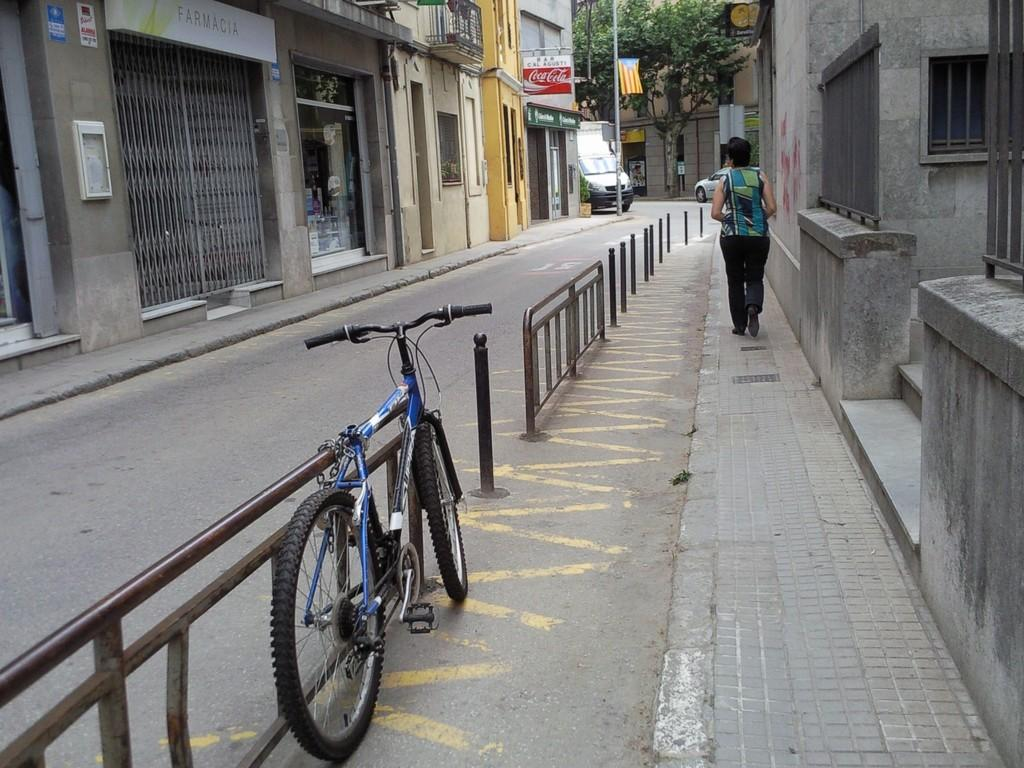What type of structures can be seen in the image? There are buildings in the image. What mode of transportation is visible in the image? There is a bicycle, a car, and a van in the image. What is the flag and banner used for in the image? The flag and banner are likely used for identification or advertising purposes. Can you describe the person in the image? There is a person walking in the image. What type of vegetation is present in the image? There are trees in the image. What color is the person's stocking in the image? There is no mention of stockings or any clothing details in the image. How many fingers can be seen on the person's hand in the image? There is no visible hand or fingers on the person in the image. 